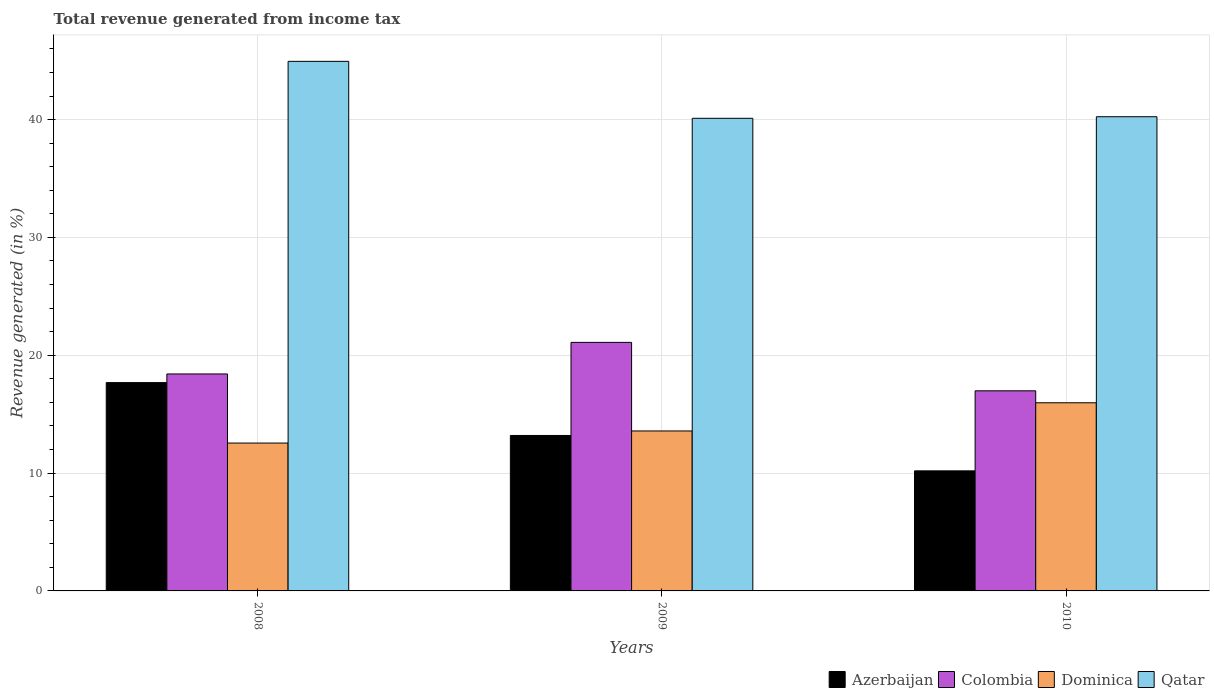How many different coloured bars are there?
Offer a very short reply. 4. Are the number of bars per tick equal to the number of legend labels?
Offer a very short reply. Yes. Are the number of bars on each tick of the X-axis equal?
Your answer should be very brief. Yes. What is the label of the 2nd group of bars from the left?
Offer a terse response. 2009. In how many cases, is the number of bars for a given year not equal to the number of legend labels?
Offer a terse response. 0. What is the total revenue generated in Qatar in 2008?
Offer a terse response. 44.94. Across all years, what is the maximum total revenue generated in Colombia?
Offer a terse response. 21.09. Across all years, what is the minimum total revenue generated in Colombia?
Provide a short and direct response. 16.98. What is the total total revenue generated in Dominica in the graph?
Ensure brevity in your answer.  42.09. What is the difference between the total revenue generated in Azerbaijan in 2008 and that in 2010?
Provide a succinct answer. 7.49. What is the difference between the total revenue generated in Dominica in 2008 and the total revenue generated in Colombia in 2010?
Offer a very short reply. -4.43. What is the average total revenue generated in Dominica per year?
Give a very brief answer. 14.03. In the year 2009, what is the difference between the total revenue generated in Colombia and total revenue generated in Dominica?
Your response must be concise. 7.52. In how many years, is the total revenue generated in Qatar greater than 24 %?
Your answer should be very brief. 3. What is the ratio of the total revenue generated in Azerbaijan in 2009 to that in 2010?
Provide a succinct answer. 1.29. Is the total revenue generated in Colombia in 2008 less than that in 2010?
Ensure brevity in your answer.  No. What is the difference between the highest and the second highest total revenue generated in Azerbaijan?
Give a very brief answer. 4.49. What is the difference between the highest and the lowest total revenue generated in Azerbaijan?
Offer a terse response. 7.49. What does the 4th bar from the left in 2008 represents?
Keep it short and to the point. Qatar. What does the 4th bar from the right in 2010 represents?
Offer a very short reply. Azerbaijan. How many bars are there?
Keep it short and to the point. 12. Does the graph contain any zero values?
Provide a succinct answer. No. Where does the legend appear in the graph?
Offer a very short reply. Bottom right. What is the title of the graph?
Offer a very short reply. Total revenue generated from income tax. Does "Somalia" appear as one of the legend labels in the graph?
Your response must be concise. No. What is the label or title of the X-axis?
Your answer should be very brief. Years. What is the label or title of the Y-axis?
Ensure brevity in your answer.  Revenue generated (in %). What is the Revenue generated (in %) of Azerbaijan in 2008?
Your answer should be compact. 17.68. What is the Revenue generated (in %) in Colombia in 2008?
Make the answer very short. 18.41. What is the Revenue generated (in %) of Dominica in 2008?
Offer a very short reply. 12.55. What is the Revenue generated (in %) in Qatar in 2008?
Make the answer very short. 44.94. What is the Revenue generated (in %) in Azerbaijan in 2009?
Give a very brief answer. 13.19. What is the Revenue generated (in %) of Colombia in 2009?
Make the answer very short. 21.09. What is the Revenue generated (in %) of Dominica in 2009?
Keep it short and to the point. 13.57. What is the Revenue generated (in %) of Qatar in 2009?
Your answer should be very brief. 40.11. What is the Revenue generated (in %) of Azerbaijan in 2010?
Provide a succinct answer. 10.19. What is the Revenue generated (in %) of Colombia in 2010?
Ensure brevity in your answer.  16.98. What is the Revenue generated (in %) of Dominica in 2010?
Keep it short and to the point. 15.97. What is the Revenue generated (in %) in Qatar in 2010?
Keep it short and to the point. 40.24. Across all years, what is the maximum Revenue generated (in %) in Azerbaijan?
Offer a very short reply. 17.68. Across all years, what is the maximum Revenue generated (in %) in Colombia?
Offer a very short reply. 21.09. Across all years, what is the maximum Revenue generated (in %) in Dominica?
Your answer should be very brief. 15.97. Across all years, what is the maximum Revenue generated (in %) in Qatar?
Make the answer very short. 44.94. Across all years, what is the minimum Revenue generated (in %) in Azerbaijan?
Ensure brevity in your answer.  10.19. Across all years, what is the minimum Revenue generated (in %) of Colombia?
Provide a short and direct response. 16.98. Across all years, what is the minimum Revenue generated (in %) of Dominica?
Ensure brevity in your answer.  12.55. Across all years, what is the minimum Revenue generated (in %) of Qatar?
Your answer should be compact. 40.11. What is the total Revenue generated (in %) in Azerbaijan in the graph?
Provide a short and direct response. 41.06. What is the total Revenue generated (in %) of Colombia in the graph?
Make the answer very short. 56.49. What is the total Revenue generated (in %) of Dominica in the graph?
Your answer should be very brief. 42.09. What is the total Revenue generated (in %) of Qatar in the graph?
Your response must be concise. 125.29. What is the difference between the Revenue generated (in %) of Azerbaijan in 2008 and that in 2009?
Provide a succinct answer. 4.49. What is the difference between the Revenue generated (in %) of Colombia in 2008 and that in 2009?
Provide a short and direct response. -2.68. What is the difference between the Revenue generated (in %) of Dominica in 2008 and that in 2009?
Offer a very short reply. -1.03. What is the difference between the Revenue generated (in %) of Qatar in 2008 and that in 2009?
Your response must be concise. 4.83. What is the difference between the Revenue generated (in %) of Azerbaijan in 2008 and that in 2010?
Your answer should be very brief. 7.49. What is the difference between the Revenue generated (in %) in Colombia in 2008 and that in 2010?
Your response must be concise. 1.43. What is the difference between the Revenue generated (in %) in Dominica in 2008 and that in 2010?
Ensure brevity in your answer.  -3.42. What is the difference between the Revenue generated (in %) in Qatar in 2008 and that in 2010?
Your answer should be very brief. 4.7. What is the difference between the Revenue generated (in %) of Azerbaijan in 2009 and that in 2010?
Your response must be concise. 3. What is the difference between the Revenue generated (in %) in Colombia in 2009 and that in 2010?
Keep it short and to the point. 4.11. What is the difference between the Revenue generated (in %) in Dominica in 2009 and that in 2010?
Ensure brevity in your answer.  -2.39. What is the difference between the Revenue generated (in %) in Qatar in 2009 and that in 2010?
Offer a very short reply. -0.13. What is the difference between the Revenue generated (in %) of Azerbaijan in 2008 and the Revenue generated (in %) of Colombia in 2009?
Provide a succinct answer. -3.41. What is the difference between the Revenue generated (in %) in Azerbaijan in 2008 and the Revenue generated (in %) in Dominica in 2009?
Provide a short and direct response. 4.1. What is the difference between the Revenue generated (in %) of Azerbaijan in 2008 and the Revenue generated (in %) of Qatar in 2009?
Give a very brief answer. -22.43. What is the difference between the Revenue generated (in %) in Colombia in 2008 and the Revenue generated (in %) in Dominica in 2009?
Offer a very short reply. 4.84. What is the difference between the Revenue generated (in %) in Colombia in 2008 and the Revenue generated (in %) in Qatar in 2009?
Provide a short and direct response. -21.7. What is the difference between the Revenue generated (in %) in Dominica in 2008 and the Revenue generated (in %) in Qatar in 2009?
Keep it short and to the point. -27.56. What is the difference between the Revenue generated (in %) in Azerbaijan in 2008 and the Revenue generated (in %) in Colombia in 2010?
Offer a very short reply. 0.7. What is the difference between the Revenue generated (in %) of Azerbaijan in 2008 and the Revenue generated (in %) of Dominica in 2010?
Provide a succinct answer. 1.71. What is the difference between the Revenue generated (in %) in Azerbaijan in 2008 and the Revenue generated (in %) in Qatar in 2010?
Your answer should be compact. -22.56. What is the difference between the Revenue generated (in %) of Colombia in 2008 and the Revenue generated (in %) of Dominica in 2010?
Keep it short and to the point. 2.45. What is the difference between the Revenue generated (in %) of Colombia in 2008 and the Revenue generated (in %) of Qatar in 2010?
Give a very brief answer. -21.83. What is the difference between the Revenue generated (in %) of Dominica in 2008 and the Revenue generated (in %) of Qatar in 2010?
Keep it short and to the point. -27.69. What is the difference between the Revenue generated (in %) of Azerbaijan in 2009 and the Revenue generated (in %) of Colombia in 2010?
Offer a very short reply. -3.79. What is the difference between the Revenue generated (in %) of Azerbaijan in 2009 and the Revenue generated (in %) of Dominica in 2010?
Your response must be concise. -2.77. What is the difference between the Revenue generated (in %) in Azerbaijan in 2009 and the Revenue generated (in %) in Qatar in 2010?
Your response must be concise. -27.05. What is the difference between the Revenue generated (in %) in Colombia in 2009 and the Revenue generated (in %) in Dominica in 2010?
Ensure brevity in your answer.  5.12. What is the difference between the Revenue generated (in %) of Colombia in 2009 and the Revenue generated (in %) of Qatar in 2010?
Provide a short and direct response. -19.15. What is the difference between the Revenue generated (in %) of Dominica in 2009 and the Revenue generated (in %) of Qatar in 2010?
Keep it short and to the point. -26.67. What is the average Revenue generated (in %) of Azerbaijan per year?
Make the answer very short. 13.69. What is the average Revenue generated (in %) of Colombia per year?
Keep it short and to the point. 18.83. What is the average Revenue generated (in %) in Dominica per year?
Provide a succinct answer. 14.03. What is the average Revenue generated (in %) in Qatar per year?
Offer a terse response. 41.76. In the year 2008, what is the difference between the Revenue generated (in %) in Azerbaijan and Revenue generated (in %) in Colombia?
Your answer should be compact. -0.73. In the year 2008, what is the difference between the Revenue generated (in %) of Azerbaijan and Revenue generated (in %) of Dominica?
Make the answer very short. 5.13. In the year 2008, what is the difference between the Revenue generated (in %) of Azerbaijan and Revenue generated (in %) of Qatar?
Your response must be concise. -27.26. In the year 2008, what is the difference between the Revenue generated (in %) in Colombia and Revenue generated (in %) in Dominica?
Your answer should be very brief. 5.86. In the year 2008, what is the difference between the Revenue generated (in %) of Colombia and Revenue generated (in %) of Qatar?
Your response must be concise. -26.53. In the year 2008, what is the difference between the Revenue generated (in %) in Dominica and Revenue generated (in %) in Qatar?
Offer a terse response. -32.39. In the year 2009, what is the difference between the Revenue generated (in %) of Azerbaijan and Revenue generated (in %) of Colombia?
Ensure brevity in your answer.  -7.9. In the year 2009, what is the difference between the Revenue generated (in %) of Azerbaijan and Revenue generated (in %) of Dominica?
Your response must be concise. -0.38. In the year 2009, what is the difference between the Revenue generated (in %) of Azerbaijan and Revenue generated (in %) of Qatar?
Your answer should be very brief. -26.92. In the year 2009, what is the difference between the Revenue generated (in %) in Colombia and Revenue generated (in %) in Dominica?
Your answer should be compact. 7.52. In the year 2009, what is the difference between the Revenue generated (in %) of Colombia and Revenue generated (in %) of Qatar?
Ensure brevity in your answer.  -19.02. In the year 2009, what is the difference between the Revenue generated (in %) of Dominica and Revenue generated (in %) of Qatar?
Keep it short and to the point. -26.53. In the year 2010, what is the difference between the Revenue generated (in %) of Azerbaijan and Revenue generated (in %) of Colombia?
Provide a short and direct response. -6.79. In the year 2010, what is the difference between the Revenue generated (in %) in Azerbaijan and Revenue generated (in %) in Dominica?
Provide a short and direct response. -5.78. In the year 2010, what is the difference between the Revenue generated (in %) of Azerbaijan and Revenue generated (in %) of Qatar?
Provide a short and direct response. -30.05. In the year 2010, what is the difference between the Revenue generated (in %) of Colombia and Revenue generated (in %) of Dominica?
Provide a short and direct response. 1.01. In the year 2010, what is the difference between the Revenue generated (in %) of Colombia and Revenue generated (in %) of Qatar?
Your response must be concise. -23.26. In the year 2010, what is the difference between the Revenue generated (in %) in Dominica and Revenue generated (in %) in Qatar?
Provide a succinct answer. -24.27. What is the ratio of the Revenue generated (in %) in Azerbaijan in 2008 to that in 2009?
Offer a very short reply. 1.34. What is the ratio of the Revenue generated (in %) of Colombia in 2008 to that in 2009?
Keep it short and to the point. 0.87. What is the ratio of the Revenue generated (in %) in Dominica in 2008 to that in 2009?
Your answer should be compact. 0.92. What is the ratio of the Revenue generated (in %) of Qatar in 2008 to that in 2009?
Give a very brief answer. 1.12. What is the ratio of the Revenue generated (in %) of Azerbaijan in 2008 to that in 2010?
Ensure brevity in your answer.  1.74. What is the ratio of the Revenue generated (in %) of Colombia in 2008 to that in 2010?
Offer a terse response. 1.08. What is the ratio of the Revenue generated (in %) in Dominica in 2008 to that in 2010?
Ensure brevity in your answer.  0.79. What is the ratio of the Revenue generated (in %) of Qatar in 2008 to that in 2010?
Give a very brief answer. 1.12. What is the ratio of the Revenue generated (in %) of Azerbaijan in 2009 to that in 2010?
Offer a terse response. 1.29. What is the ratio of the Revenue generated (in %) in Colombia in 2009 to that in 2010?
Give a very brief answer. 1.24. What is the ratio of the Revenue generated (in %) of Dominica in 2009 to that in 2010?
Keep it short and to the point. 0.85. What is the difference between the highest and the second highest Revenue generated (in %) of Azerbaijan?
Provide a succinct answer. 4.49. What is the difference between the highest and the second highest Revenue generated (in %) of Colombia?
Your answer should be compact. 2.68. What is the difference between the highest and the second highest Revenue generated (in %) of Dominica?
Your response must be concise. 2.39. What is the difference between the highest and the second highest Revenue generated (in %) of Qatar?
Your answer should be very brief. 4.7. What is the difference between the highest and the lowest Revenue generated (in %) of Azerbaijan?
Keep it short and to the point. 7.49. What is the difference between the highest and the lowest Revenue generated (in %) in Colombia?
Keep it short and to the point. 4.11. What is the difference between the highest and the lowest Revenue generated (in %) of Dominica?
Offer a very short reply. 3.42. What is the difference between the highest and the lowest Revenue generated (in %) of Qatar?
Provide a succinct answer. 4.83. 